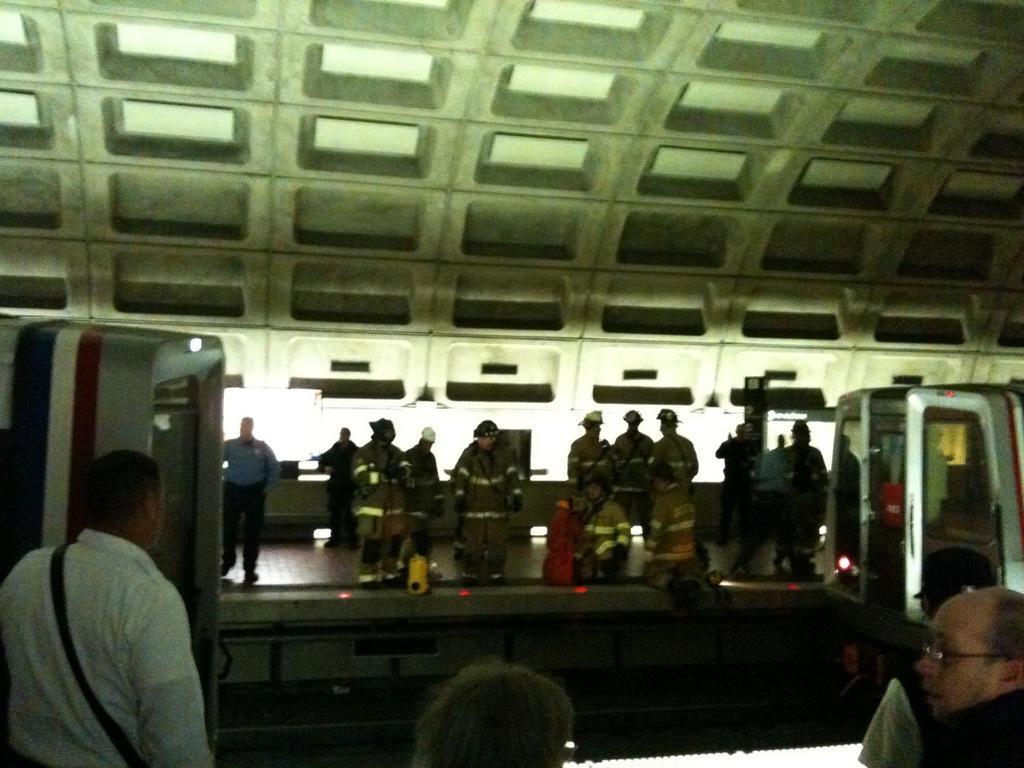Could you give a brief overview of what you see in this image? In this picture there is a train and there are few persons standing on either sides of it on the platform. 